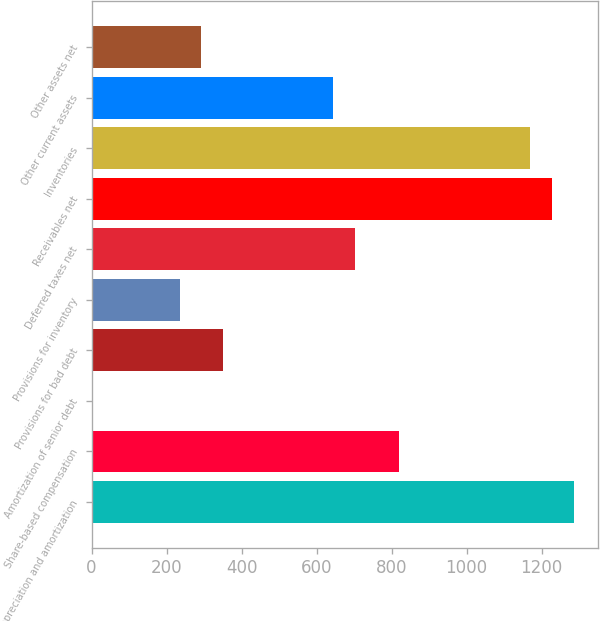<chart> <loc_0><loc_0><loc_500><loc_500><bar_chart><fcel>Depreciation and amortization<fcel>Share-based compensation<fcel>Amortization of senior debt<fcel>Provisions for bad debt<fcel>Provisions for inventory<fcel>Deferred taxes net<fcel>Receivables net<fcel>Inventories<fcel>Other current assets<fcel>Other assets net<nl><fcel>1286.46<fcel>819.02<fcel>1<fcel>351.58<fcel>234.72<fcel>702.16<fcel>1228.03<fcel>1169.6<fcel>643.73<fcel>293.15<nl></chart> 